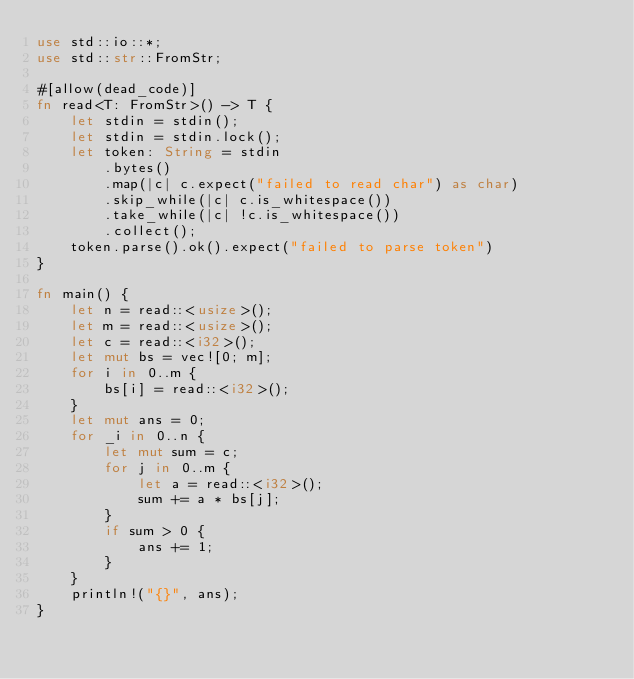<code> <loc_0><loc_0><loc_500><loc_500><_Rust_>use std::io::*;
use std::str::FromStr;

#[allow(dead_code)]
fn read<T: FromStr>() -> T {
    let stdin = stdin();
    let stdin = stdin.lock();
    let token: String = stdin
        .bytes()
        .map(|c| c.expect("failed to read char") as char)
        .skip_while(|c| c.is_whitespace())
        .take_while(|c| !c.is_whitespace())
        .collect();
    token.parse().ok().expect("failed to parse token")
}

fn main() {
    let n = read::<usize>();
    let m = read::<usize>();
    let c = read::<i32>();
    let mut bs = vec![0; m];
    for i in 0..m {
        bs[i] = read::<i32>();
    }
    let mut ans = 0;
    for _i in 0..n {
        let mut sum = c;
        for j in 0..m {
            let a = read::<i32>();
            sum += a * bs[j];
        }
        if sum > 0 {
            ans += 1;
        }
    }
    println!("{}", ans);
}
</code> 